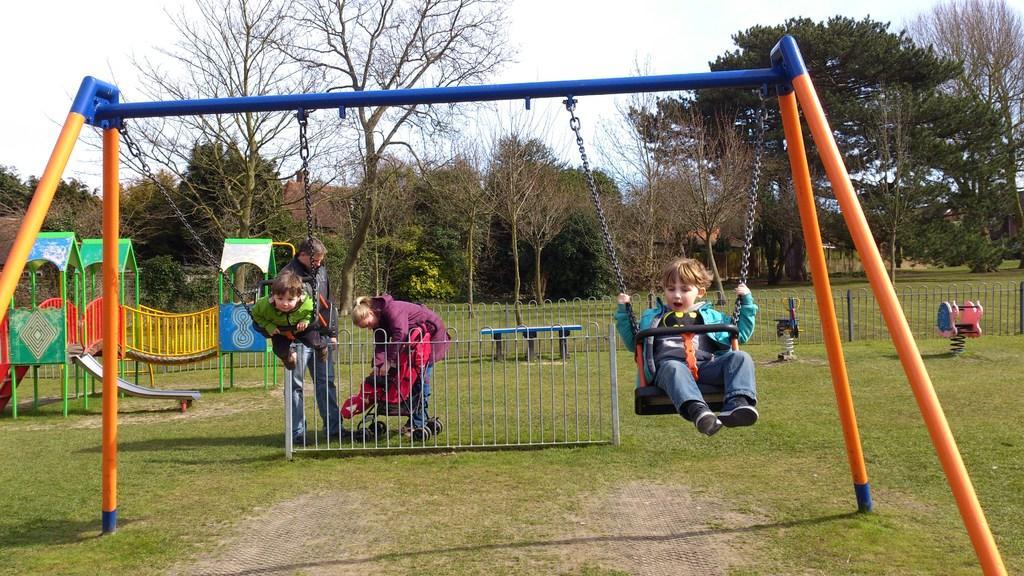How would you summarize this image in a sentence or two? This is the picture of a place where we have two kids on the swings and behind there is a fencing and a slide and some trees, plants and some grass on the floor. 